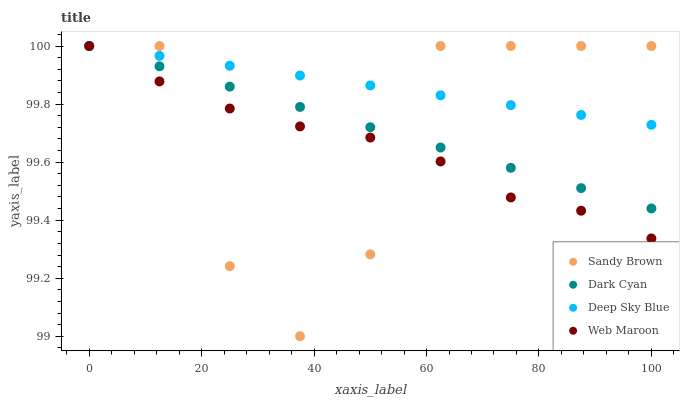Does Web Maroon have the minimum area under the curve?
Answer yes or no. Yes. Does Deep Sky Blue have the maximum area under the curve?
Answer yes or no. Yes. Does Sandy Brown have the minimum area under the curve?
Answer yes or no. No. Does Sandy Brown have the maximum area under the curve?
Answer yes or no. No. Is Deep Sky Blue the smoothest?
Answer yes or no. Yes. Is Sandy Brown the roughest?
Answer yes or no. Yes. Is Web Maroon the smoothest?
Answer yes or no. No. Is Web Maroon the roughest?
Answer yes or no. No. Does Sandy Brown have the lowest value?
Answer yes or no. Yes. Does Web Maroon have the lowest value?
Answer yes or no. No. Does Deep Sky Blue have the highest value?
Answer yes or no. Yes. Does Dark Cyan intersect Sandy Brown?
Answer yes or no. Yes. Is Dark Cyan less than Sandy Brown?
Answer yes or no. No. Is Dark Cyan greater than Sandy Brown?
Answer yes or no. No. 